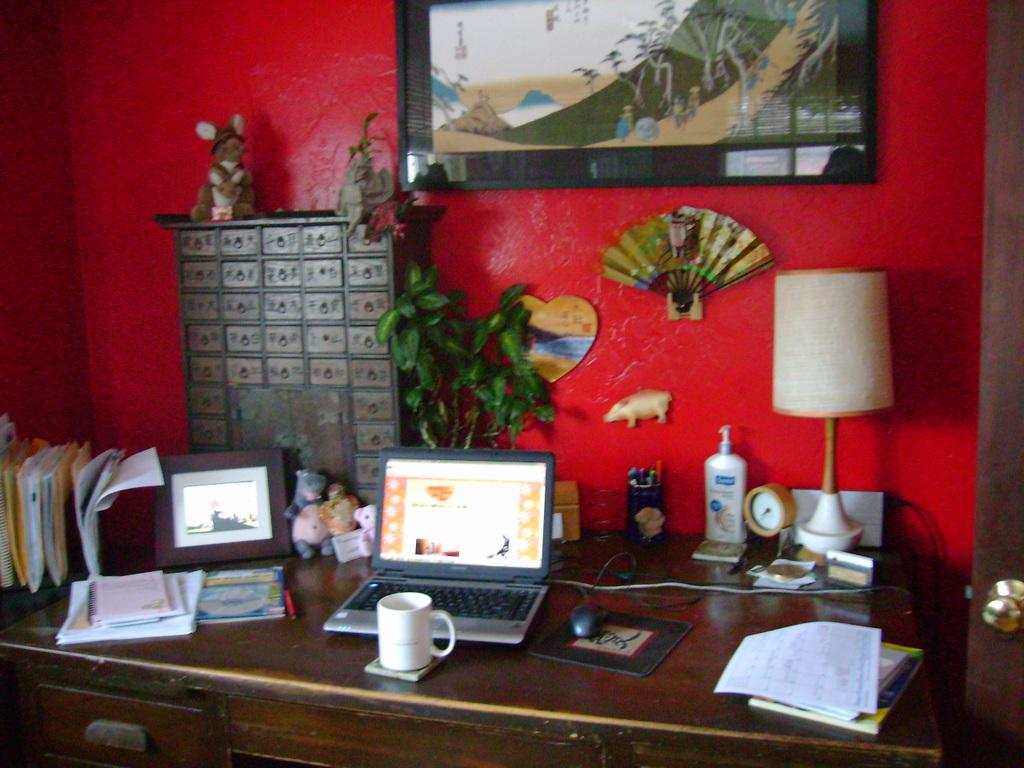What is on the table in the image? There is a cup, a laptop, papers, books, a photo frame, a lamp, and a plant on the table in the image. What color is the wall behind the table? The wall behind the table is red. Are there any other items on the wall besides the table? Yes, there is a photo frame on the red-colored wall. What is the opinion of the doll in the image? There is no doll present in the image, so it is not possible to determine its opinion. 